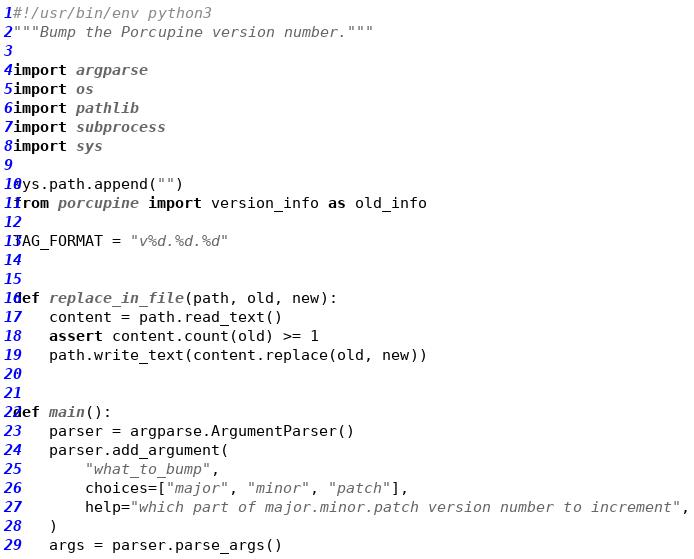Convert code to text. <code><loc_0><loc_0><loc_500><loc_500><_Python_>#!/usr/bin/env python3
"""Bump the Porcupine version number."""

import argparse
import os
import pathlib
import subprocess
import sys

sys.path.append("")
from porcupine import version_info as old_info

TAG_FORMAT = "v%d.%d.%d"


def replace_in_file(path, old, new):
    content = path.read_text()
    assert content.count(old) >= 1
    path.write_text(content.replace(old, new))


def main():
    parser = argparse.ArgumentParser()
    parser.add_argument(
        "what_to_bump",
        choices=["major", "minor", "patch"],
        help="which part of major.minor.patch version number to increment",
    )
    args = parser.parse_args()
</code> 